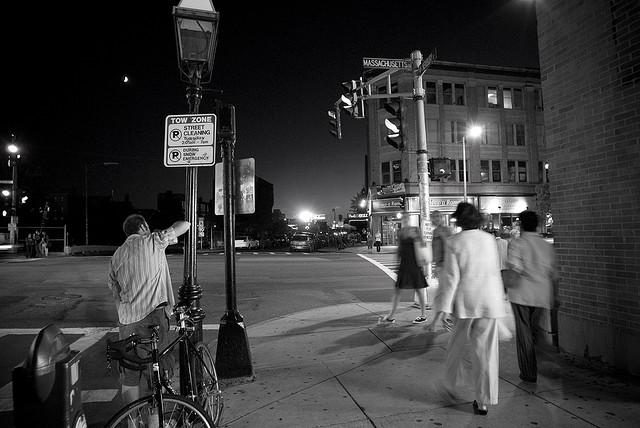What street name or intersection can be clearly seen on the corner? Please explain your reasoning. massachusetts. The name is on the sign on the pole 